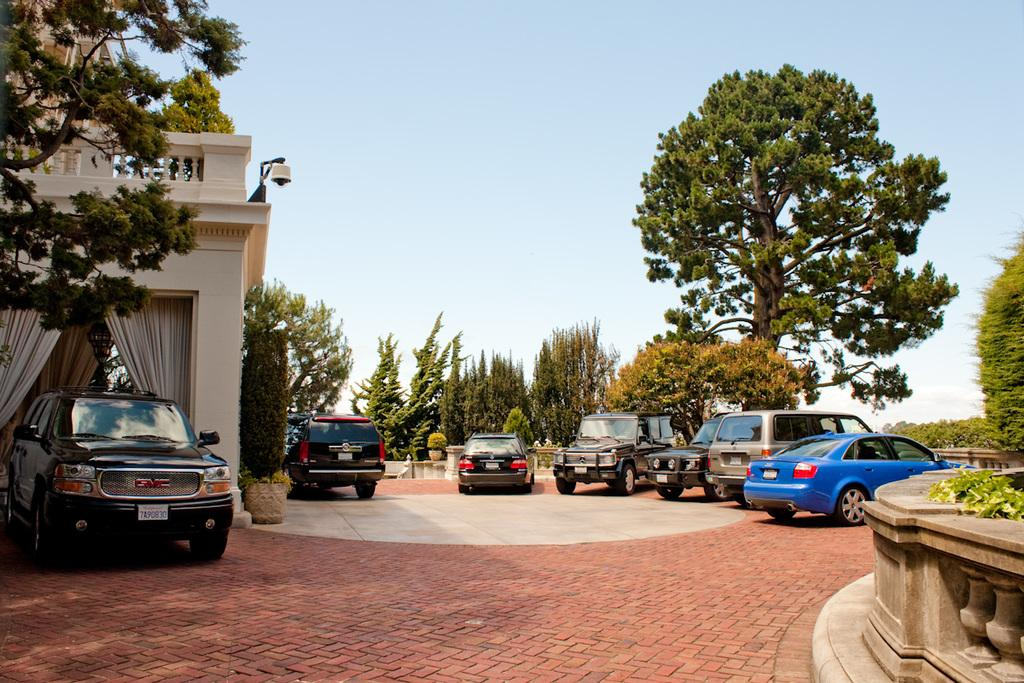What can be seen on the path in the image? There are vehicles parked on the path in the image. What type of natural elements are present in the image? There are trees and plants in the image. What architectural features can be observed in the image? There are pillars, curtains, railings, and pots in the image. What is visible in the background of the image? The sky is visible in the background of the image. How many dogs are tied to the railings in the image? There are no dogs present in the image. What type of neck accessory is hanging from the pillar in the image? There is no neck accessory present in the image. 